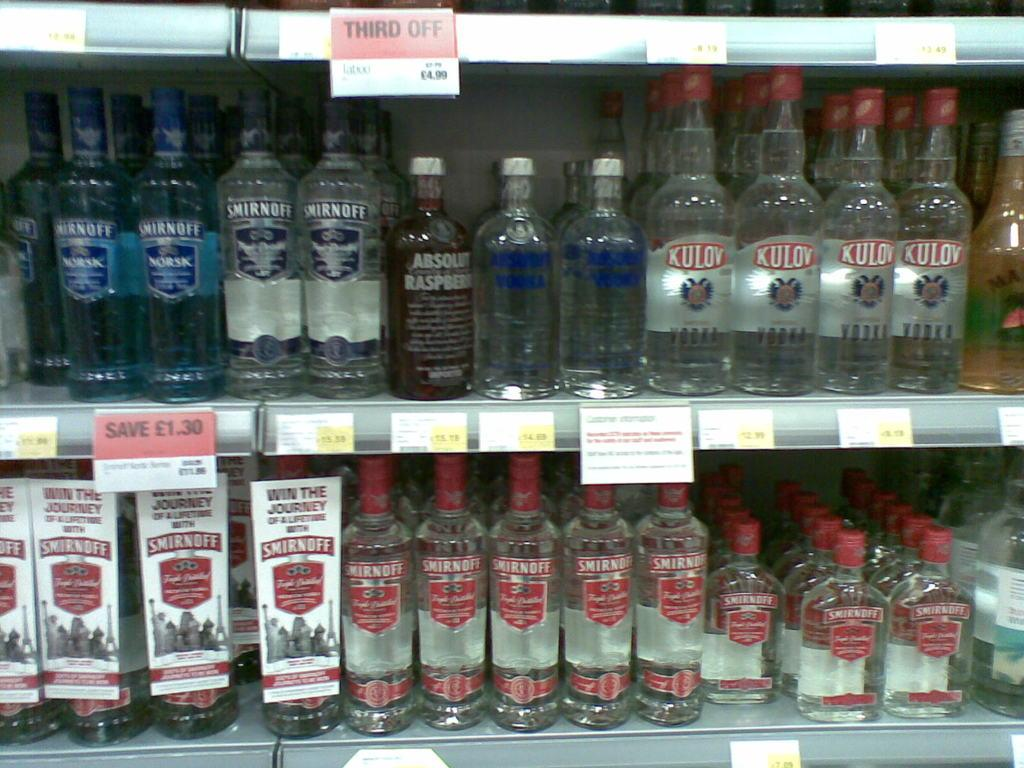Provide a one-sentence caption for the provided image. Two shelves filled with glass alcoholic bottles of Smirnoff, Absolute and Kulov brands. 